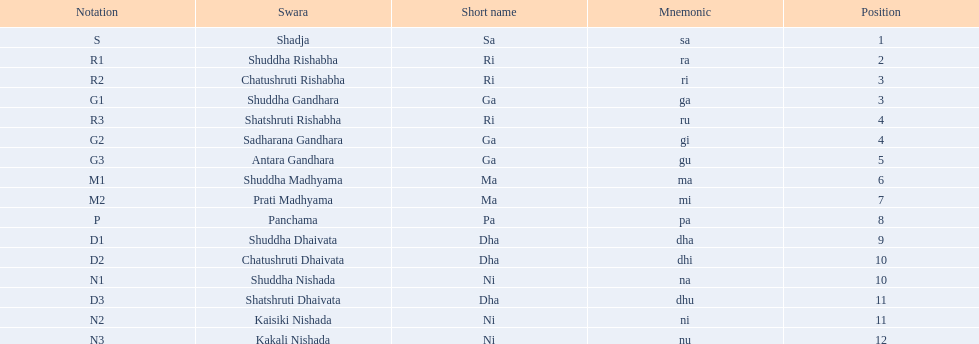What is the total number of positions listed? 16. 